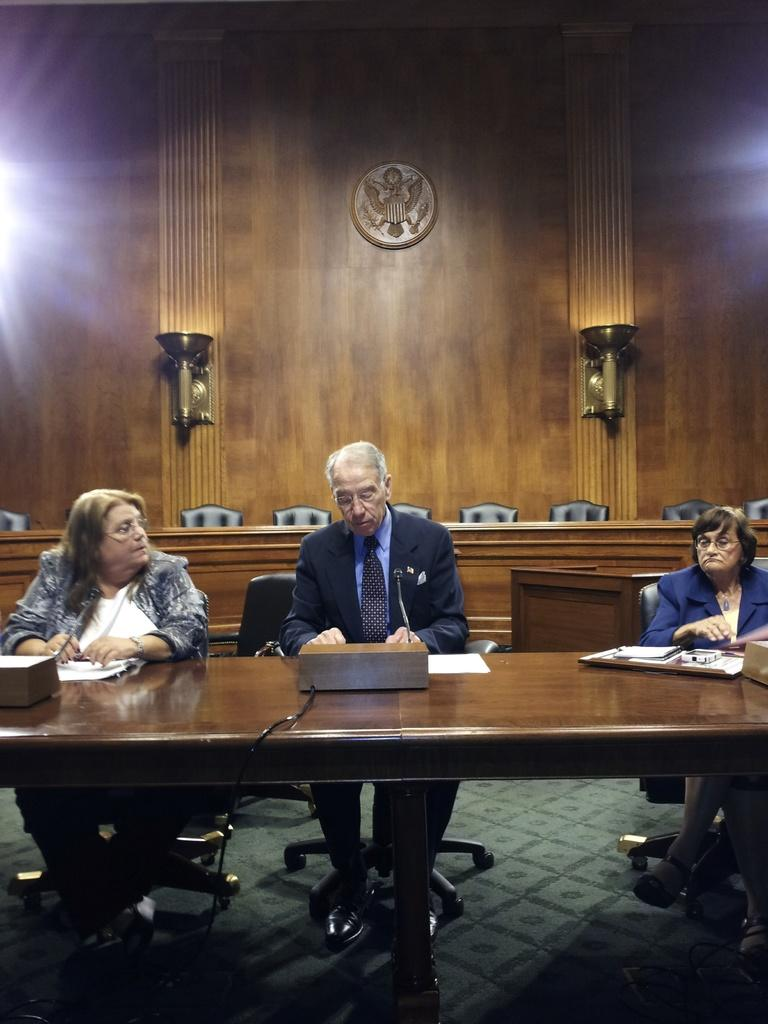How many people are in the image? There are three persons in the image. What are the persons doing in the image? The persons are sitting on chairs. Where are the chairs located in relation to each other? The chairs are around a table. What can be seen in the background of the image? There is a wall and another table and chairs in the background of the image. What color is the paint on the wall in the image? There is no mention of paint or a specific color on the wall in the image. 